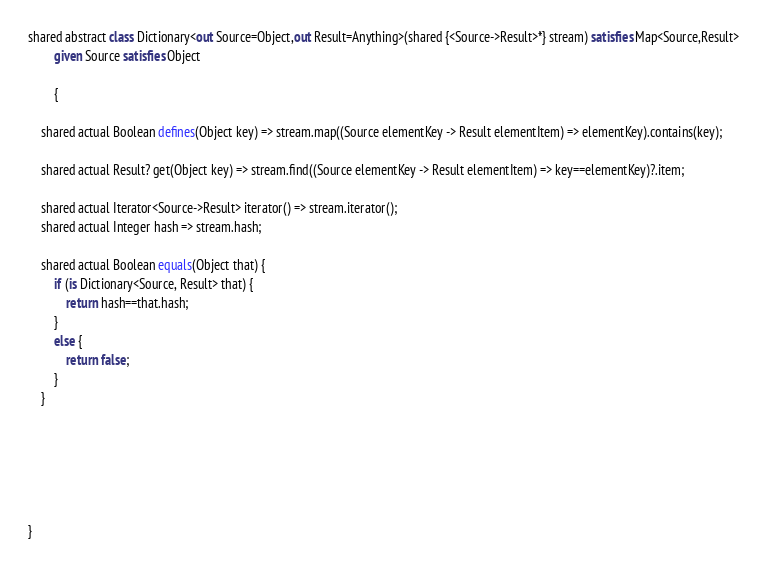Convert code to text. <code><loc_0><loc_0><loc_500><loc_500><_Ceylon_>shared abstract class Dictionary<out Source=Object,out Result=Anything>(shared {<Source->Result>*} stream) satisfies Map<Source,Result>
		given Source satisfies Object

		{
	
	shared actual Boolean defines(Object key) => stream.map((Source elementKey -> Result elementItem) => elementKey).contains(key);
	
	shared actual Result? get(Object key) => stream.find((Source elementKey -> Result elementItem) => key==elementKey)?.item;
	
	shared actual Iterator<Source->Result> iterator() => stream.iterator();
	shared actual Integer hash => stream.hash;
	
	shared actual Boolean equals(Object that) {
		if (is Dictionary<Source, Result> that) {
			return hash==that.hash;
		}
		else {
			return false;
		}
	}
	
	
	
	
	
	
} </code> 